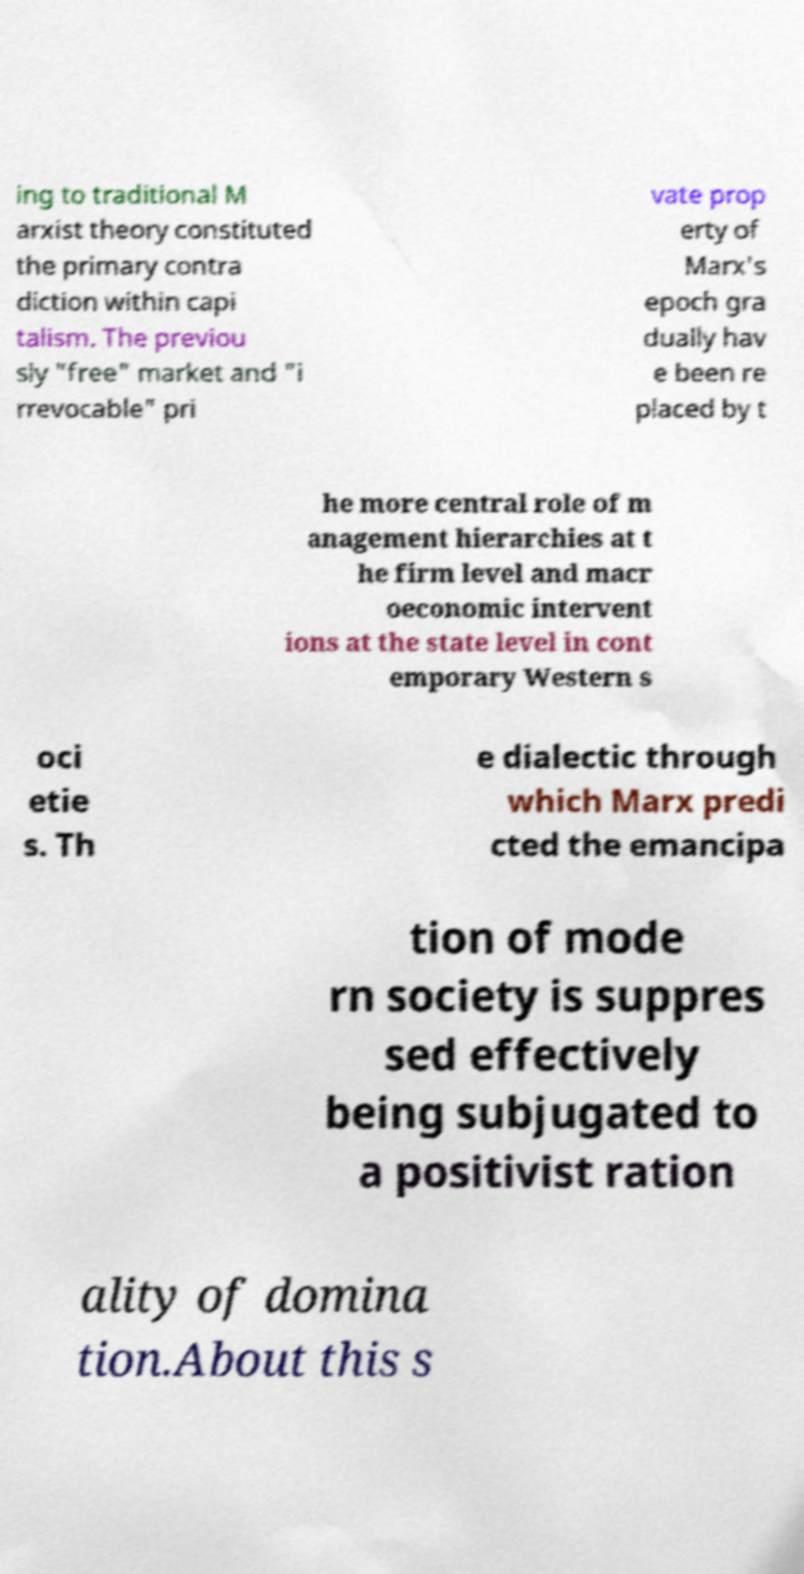What messages or text are displayed in this image? I need them in a readable, typed format. ing to traditional M arxist theory constituted the primary contra diction within capi talism. The previou sly "free" market and "i rrevocable" pri vate prop erty of Marx's epoch gra dually hav e been re placed by t he more central role of m anagement hierarchies at t he firm level and macr oeconomic intervent ions at the state level in cont emporary Western s oci etie s. Th e dialectic through which Marx predi cted the emancipa tion of mode rn society is suppres sed effectively being subjugated to a positivist ration ality of domina tion.About this s 